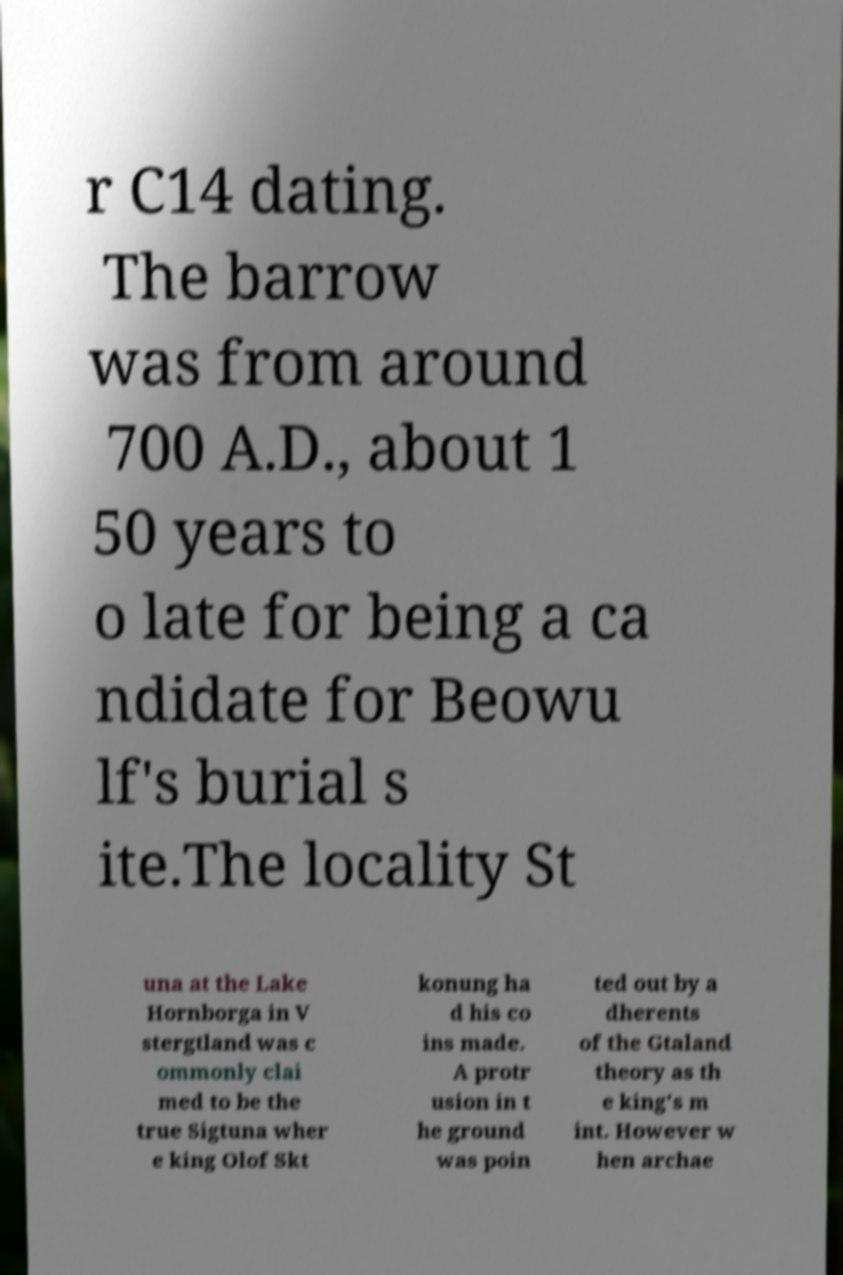Please read and relay the text visible in this image. What does it say? r C14 dating. The barrow was from around 700 A.D., about 1 50 years to o late for being a ca ndidate for Beowu lf's burial s ite.The locality St una at the Lake Hornborga in V stergtland was c ommonly clai med to be the true Sigtuna wher e king Olof Skt konung ha d his co ins made. A protr usion in t he ground was poin ted out by a dherents of the Gtaland theory as th e king's m int. However w hen archae 